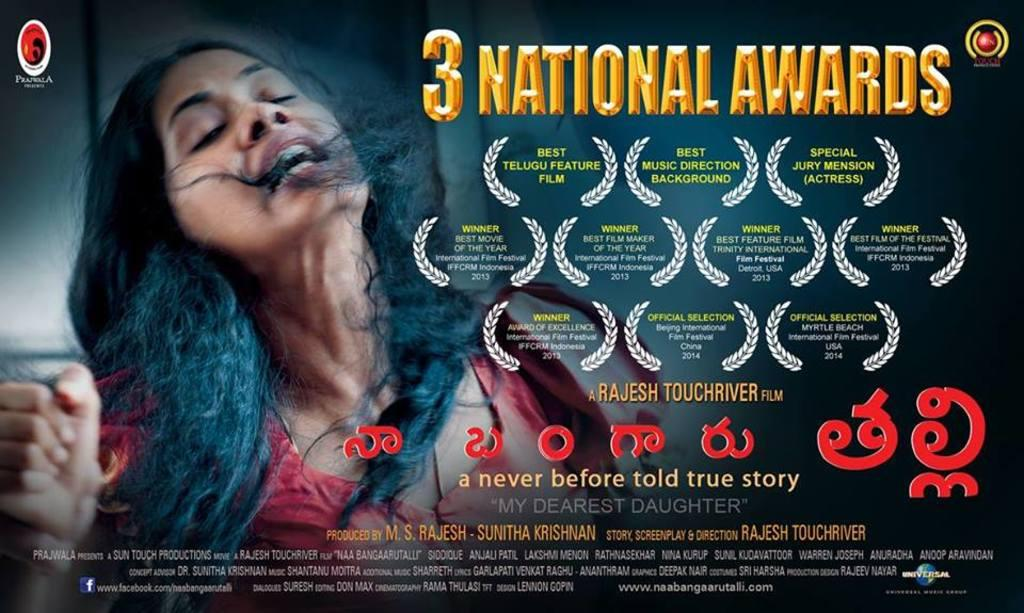<image>
Present a compact description of the photo's key features. A poster advertises 3 national awards for their movie. 